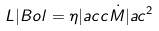<formula> <loc_0><loc_0><loc_500><loc_500>L | { B o l } = \eta | { a c c } \dot { M } | a c ^ { 2 }</formula> 